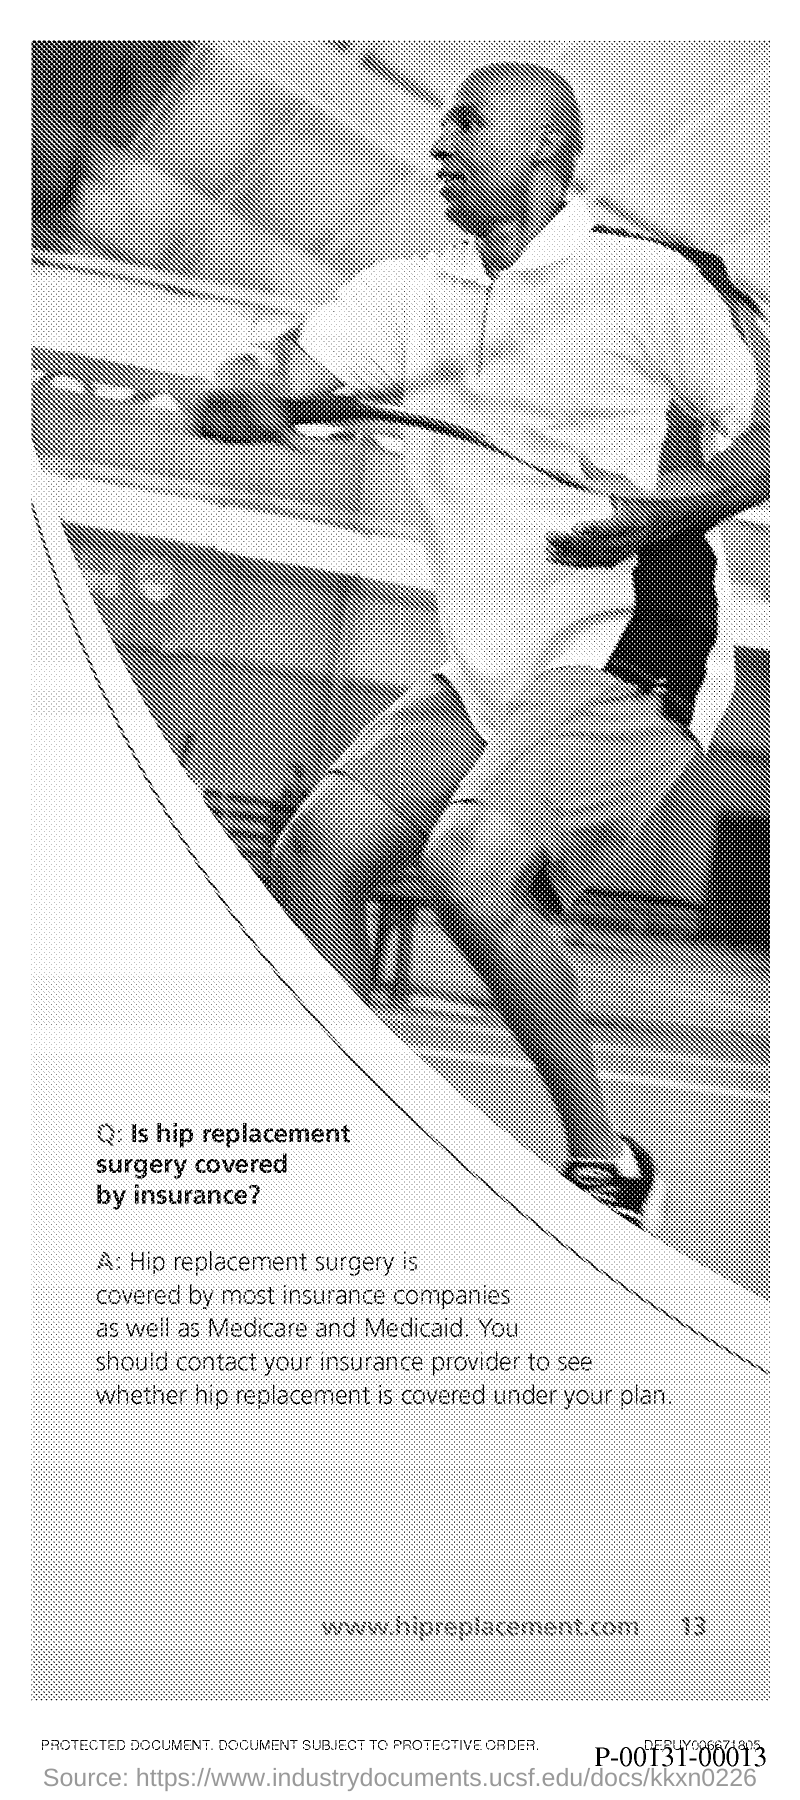What is the website in the document?
Provide a short and direct response. Www.hipreplacement.com. What is the Page Number?
Your response must be concise. 13. 